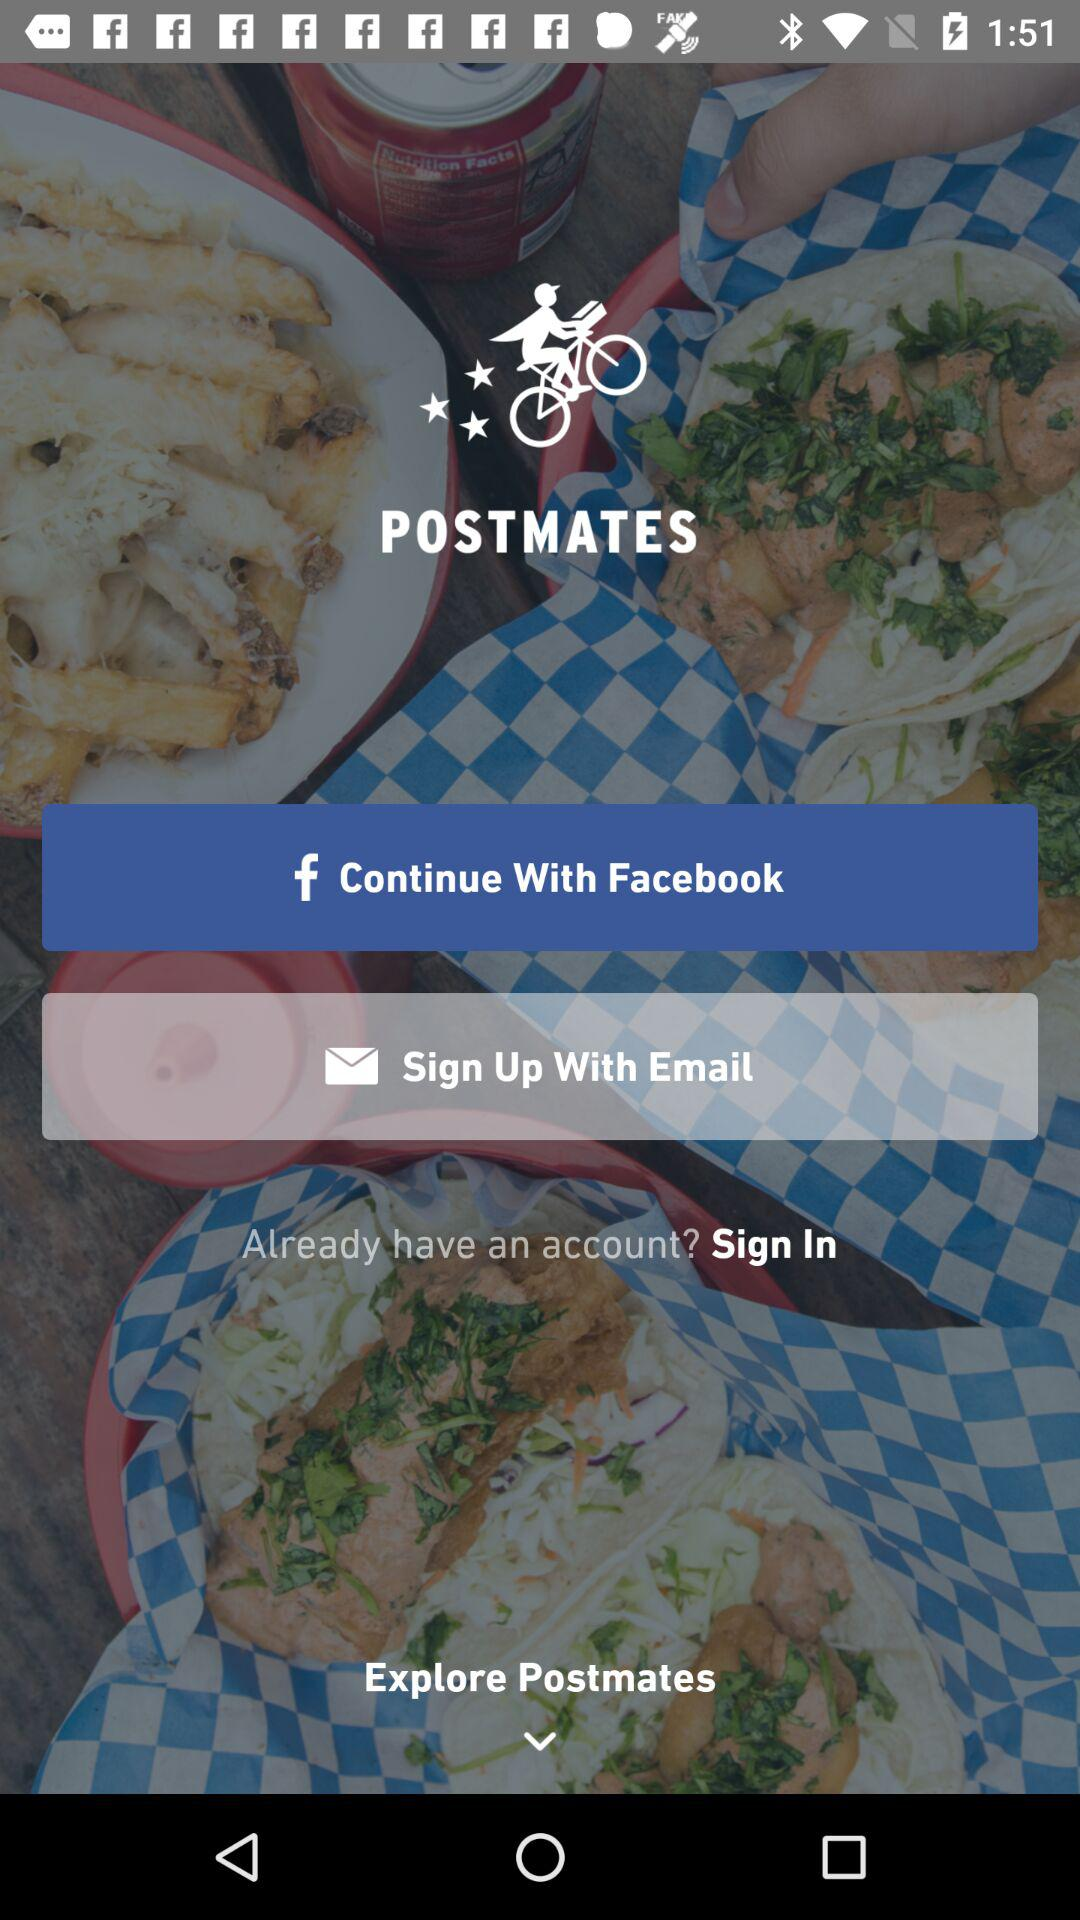What is the name of the application? The name of the application is "POSTMATES". 